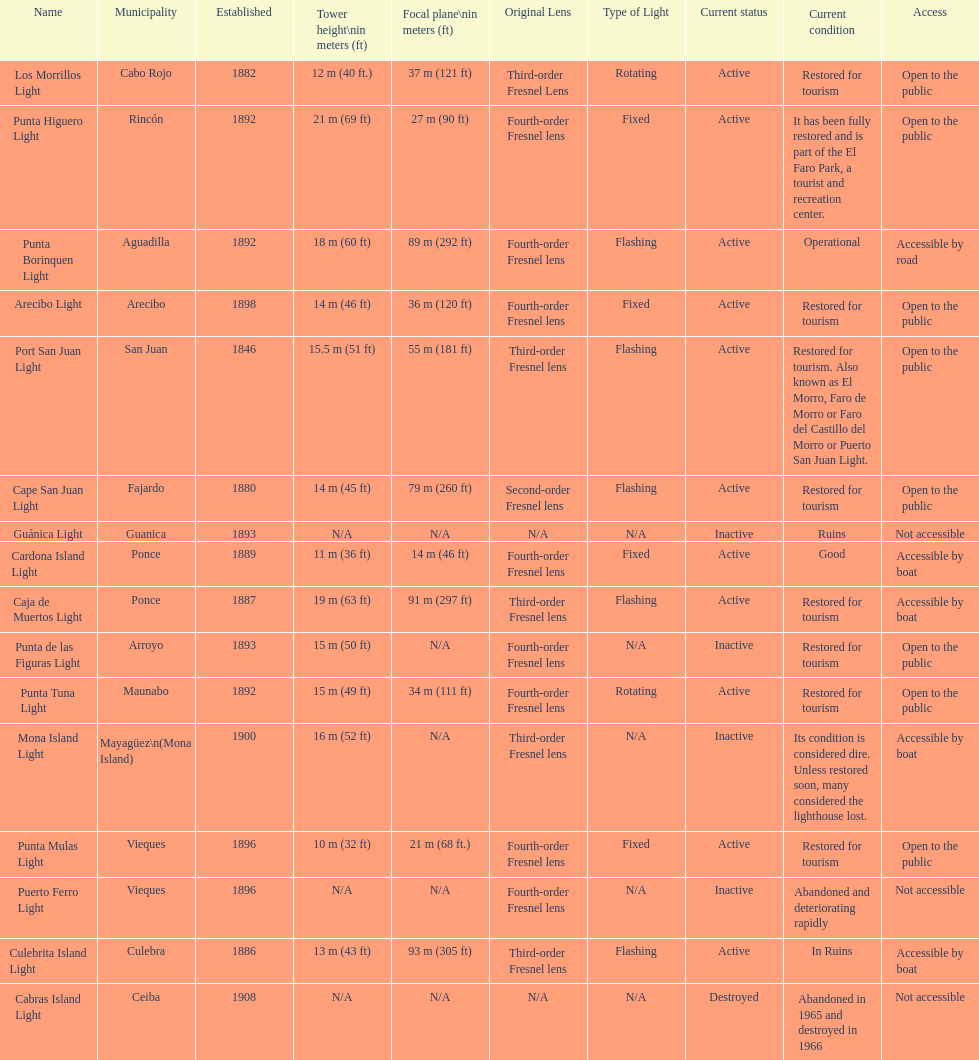How many establishments are restored for tourism? 9. 